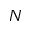<formula> <loc_0><loc_0><loc_500><loc_500>N</formula> 